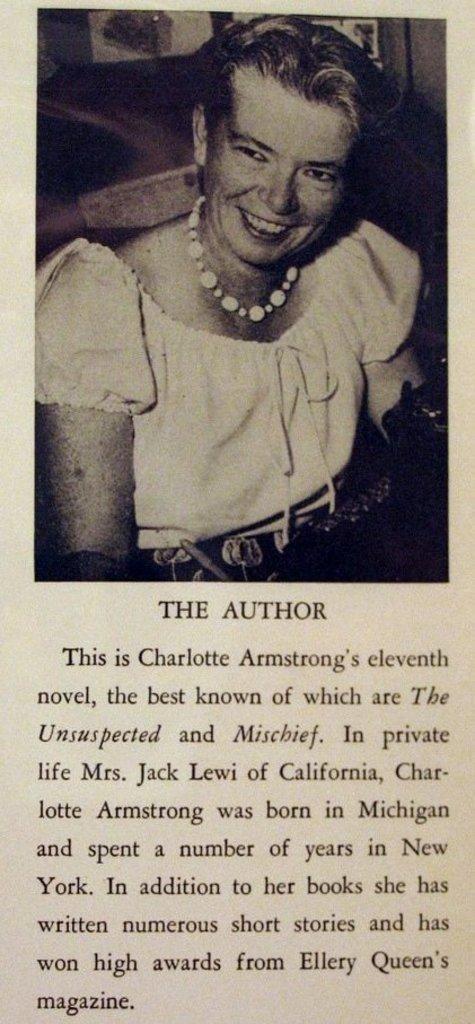How would you summarize this image in a sentence or two? This is a magazine. This is a black and white picture. At the top of the image we can see a lady is sitting on a chair and smiling. In the background of the image we can see the wall and papers. At the bottom of the image we can see the text. 